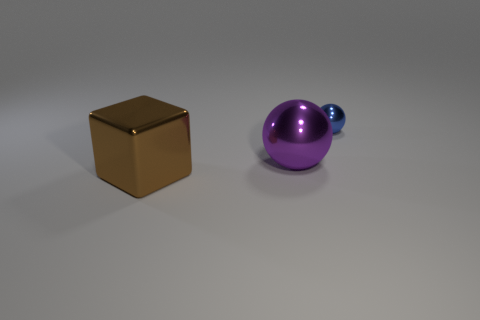What number of cylinders are big purple metallic objects or brown metallic things?
Provide a succinct answer. 0. Does the shiny ball that is to the right of the big purple ball have the same size as the shiny sphere that is in front of the tiny blue object?
Provide a succinct answer. No. The sphere that is behind the ball that is on the left side of the blue metal object is made of what material?
Give a very brief answer. Metal. Are there fewer metal blocks on the right side of the big purple metallic sphere than large brown metallic objects?
Your answer should be compact. Yes. There is a brown thing that is made of the same material as the blue ball; what shape is it?
Give a very brief answer. Cube. What number of other things are there of the same shape as the blue metal object?
Keep it short and to the point. 1. What number of red things are either big rubber spheres or large metallic spheres?
Keep it short and to the point. 0. Do the brown shiny thing and the blue metallic thing have the same shape?
Give a very brief answer. No. Is there a purple metallic sphere that is on the left side of the ball on the left side of the small blue metal ball?
Make the answer very short. No. Are there an equal number of large brown shiny things behind the tiny blue ball and big balls?
Provide a short and direct response. No. 